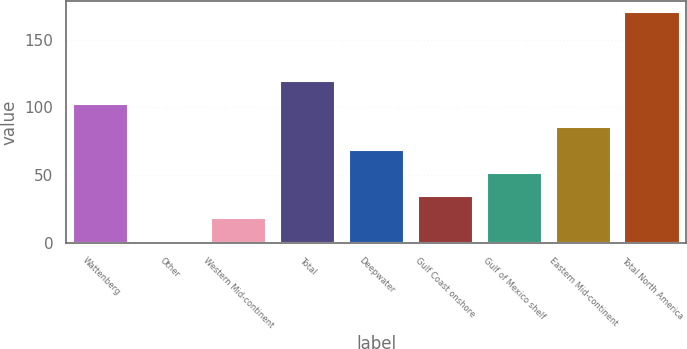Convert chart. <chart><loc_0><loc_0><loc_500><loc_500><bar_chart><fcel>Wattenberg<fcel>Other<fcel>Western Mid-continent<fcel>Total<fcel>Deepwater<fcel>Gulf Coast onshore<fcel>Gulf of Mexico shelf<fcel>Eastern Mid-continent<fcel>Total North America<nl><fcel>102.4<fcel>1<fcel>17.9<fcel>119.3<fcel>68.6<fcel>34.8<fcel>51.7<fcel>85.5<fcel>170<nl></chart> 